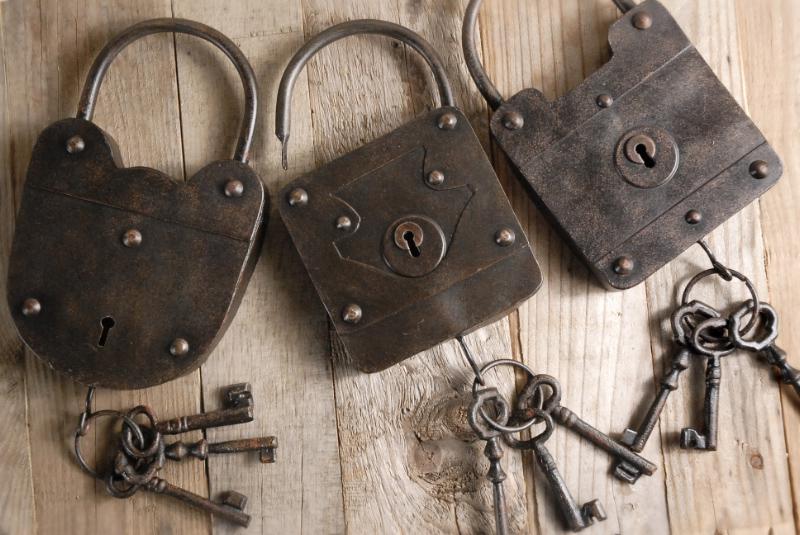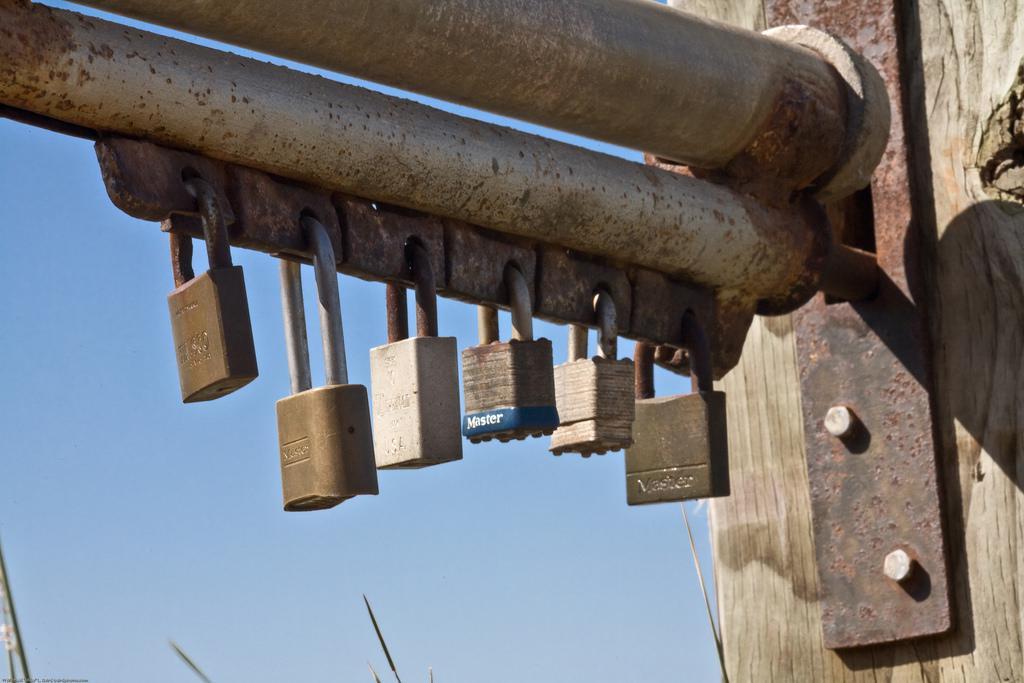The first image is the image on the left, the second image is the image on the right. Given the left and right images, does the statement "There is one lock without a key in the right image." hold true? Answer yes or no. No. The first image is the image on the left, the second image is the image on the right. For the images shown, is this caption "There is more than one lock in the right image." true? Answer yes or no. Yes. 